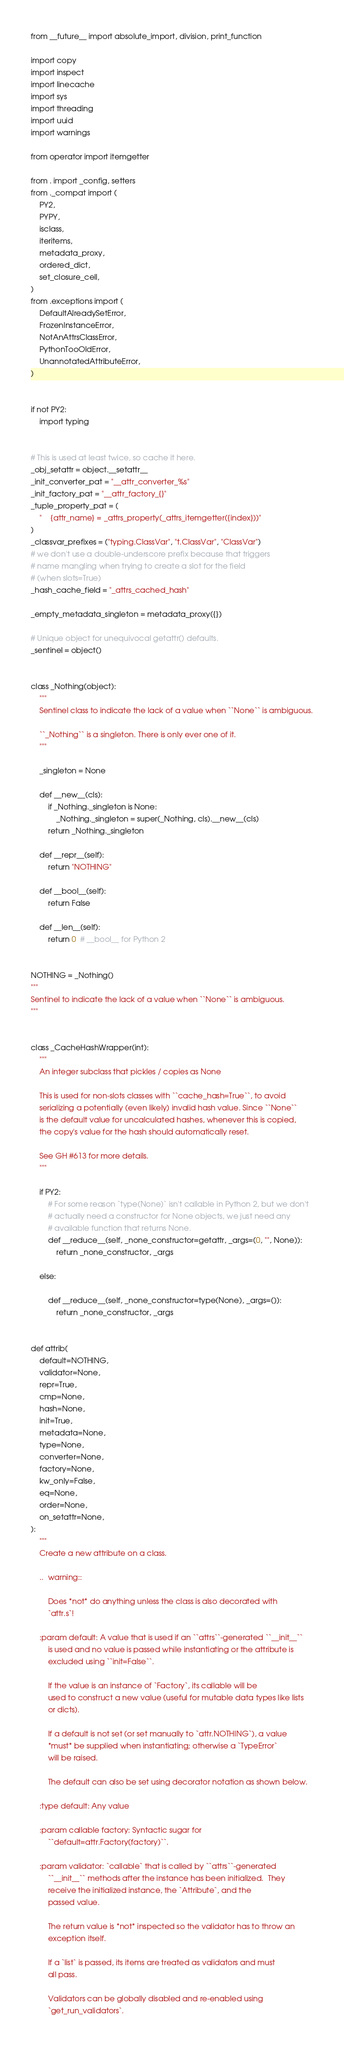<code> <loc_0><loc_0><loc_500><loc_500><_Python_>from __future__ import absolute_import, division, print_function

import copy
import inspect
import linecache
import sys
import threading
import uuid
import warnings

from operator import itemgetter

from . import _config, setters
from ._compat import (
    PY2,
    PYPY,
    isclass,
    iteritems,
    metadata_proxy,
    ordered_dict,
    set_closure_cell,
)
from .exceptions import (
    DefaultAlreadySetError,
    FrozenInstanceError,
    NotAnAttrsClassError,
    PythonTooOldError,
    UnannotatedAttributeError,
)


if not PY2:
    import typing


# This is used at least twice, so cache it here.
_obj_setattr = object.__setattr__
_init_converter_pat = "__attr_converter_%s"
_init_factory_pat = "__attr_factory_{}"
_tuple_property_pat = (
    "    {attr_name} = _attrs_property(_attrs_itemgetter({index}))"
)
_classvar_prefixes = ("typing.ClassVar", "t.ClassVar", "ClassVar")
# we don't use a double-underscore prefix because that triggers
# name mangling when trying to create a slot for the field
# (when slots=True)
_hash_cache_field = "_attrs_cached_hash"

_empty_metadata_singleton = metadata_proxy({})

# Unique object for unequivocal getattr() defaults.
_sentinel = object()


class _Nothing(object):
    """
    Sentinel class to indicate the lack of a value when ``None`` is ambiguous.

    ``_Nothing`` is a singleton. There is only ever one of it.
    """

    _singleton = None

    def __new__(cls):
        if _Nothing._singleton is None:
            _Nothing._singleton = super(_Nothing, cls).__new__(cls)
        return _Nothing._singleton

    def __repr__(self):
        return "NOTHING"

    def __bool__(self):
        return False

    def __len__(self):
        return 0  # __bool__ for Python 2


NOTHING = _Nothing()
"""
Sentinel to indicate the lack of a value when ``None`` is ambiguous.
"""


class _CacheHashWrapper(int):
    """
    An integer subclass that pickles / copies as None

    This is used for non-slots classes with ``cache_hash=True``, to avoid
    serializing a potentially (even likely) invalid hash value. Since ``None``
    is the default value for uncalculated hashes, whenever this is copied,
    the copy's value for the hash should automatically reset.

    See GH #613 for more details.
    """

    if PY2:
        # For some reason `type(None)` isn't callable in Python 2, but we don't
        # actually need a constructor for None objects, we just need any
        # available function that returns None.
        def __reduce__(self, _none_constructor=getattr, _args=(0, "", None)):
            return _none_constructor, _args

    else:

        def __reduce__(self, _none_constructor=type(None), _args=()):
            return _none_constructor, _args


def attrib(
    default=NOTHING,
    validator=None,
    repr=True,
    cmp=None,
    hash=None,
    init=True,
    metadata=None,
    type=None,
    converter=None,
    factory=None,
    kw_only=False,
    eq=None,
    order=None,
    on_setattr=None,
):
    """
    Create a new attribute on a class.

    ..  warning::

        Does *not* do anything unless the class is also decorated with
        `attr.s`!

    :param default: A value that is used if an ``attrs``-generated ``__init__``
        is used and no value is passed while instantiating or the attribute is
        excluded using ``init=False``.

        If the value is an instance of `Factory`, its callable will be
        used to construct a new value (useful for mutable data types like lists
        or dicts).

        If a default is not set (or set manually to `attr.NOTHING`), a value
        *must* be supplied when instantiating; otherwise a `TypeError`
        will be raised.

        The default can also be set using decorator notation as shown below.

    :type default: Any value

    :param callable factory: Syntactic sugar for
        ``default=attr.Factory(factory)``.

    :param validator: `callable` that is called by ``attrs``-generated
        ``__init__`` methods after the instance has been initialized.  They
        receive the initialized instance, the `Attribute`, and the
        passed value.

        The return value is *not* inspected so the validator has to throw an
        exception itself.

        If a `list` is passed, its items are treated as validators and must
        all pass.

        Validators can be globally disabled and re-enabled using
        `get_run_validators`.
</code> 